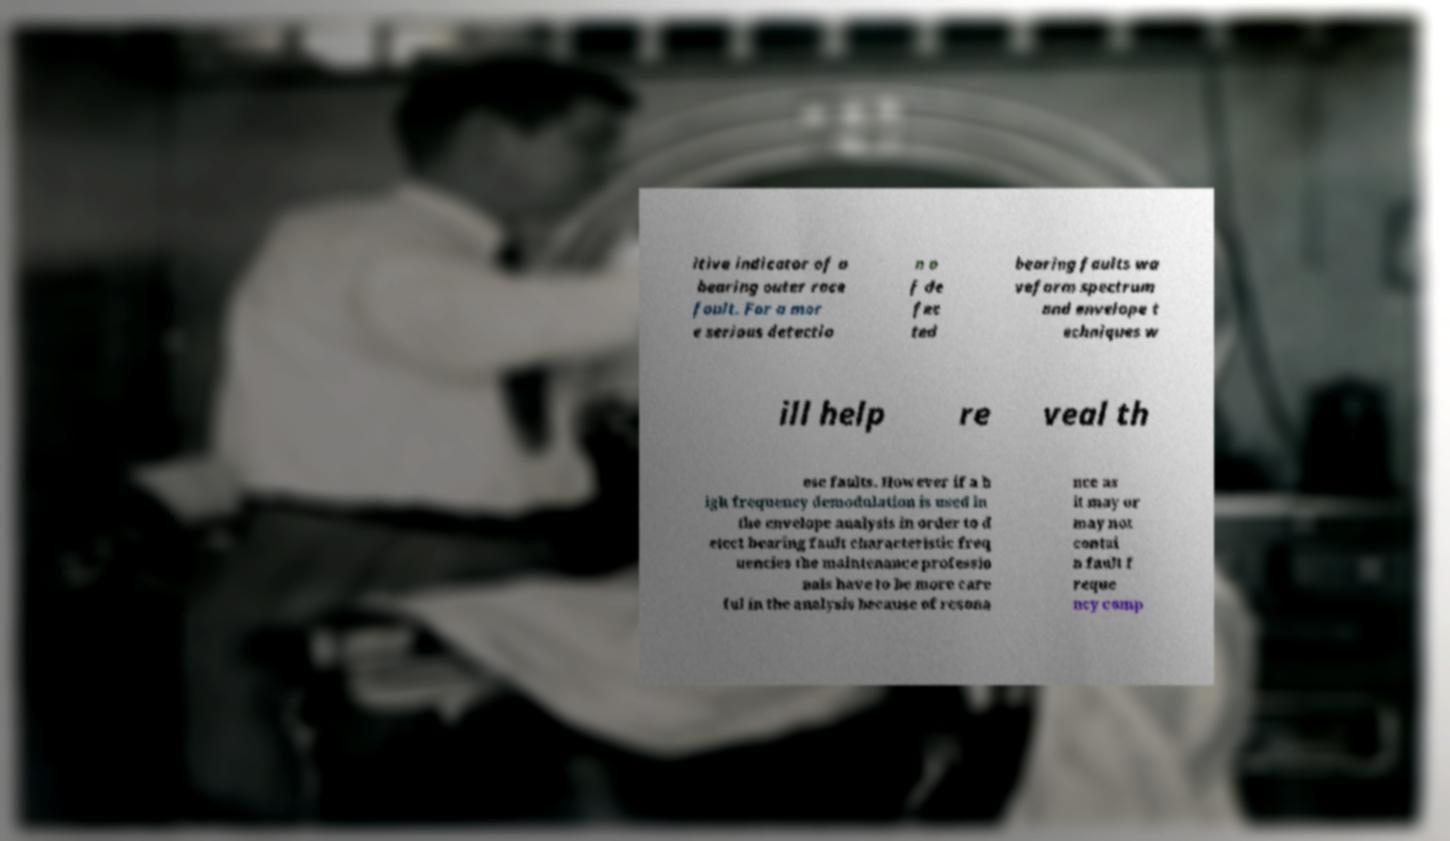Can you accurately transcribe the text from the provided image for me? itive indicator of a bearing outer race fault. For a mor e serious detectio n o f de fec ted bearing faults wa veform spectrum and envelope t echniques w ill help re veal th ese faults. However if a h igh frequency demodulation is used in the envelope analysis in order to d etect bearing fault characteristic freq uencies the maintenance professio nals have to be more care ful in the analysis because of resona nce as it may or may not contai n fault f reque ncy comp 